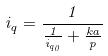<formula> <loc_0><loc_0><loc_500><loc_500>i _ { q } = \frac { 1 } { \frac { 1 } { i _ { q _ { 0 } } } + \frac { k a } { p } }</formula> 